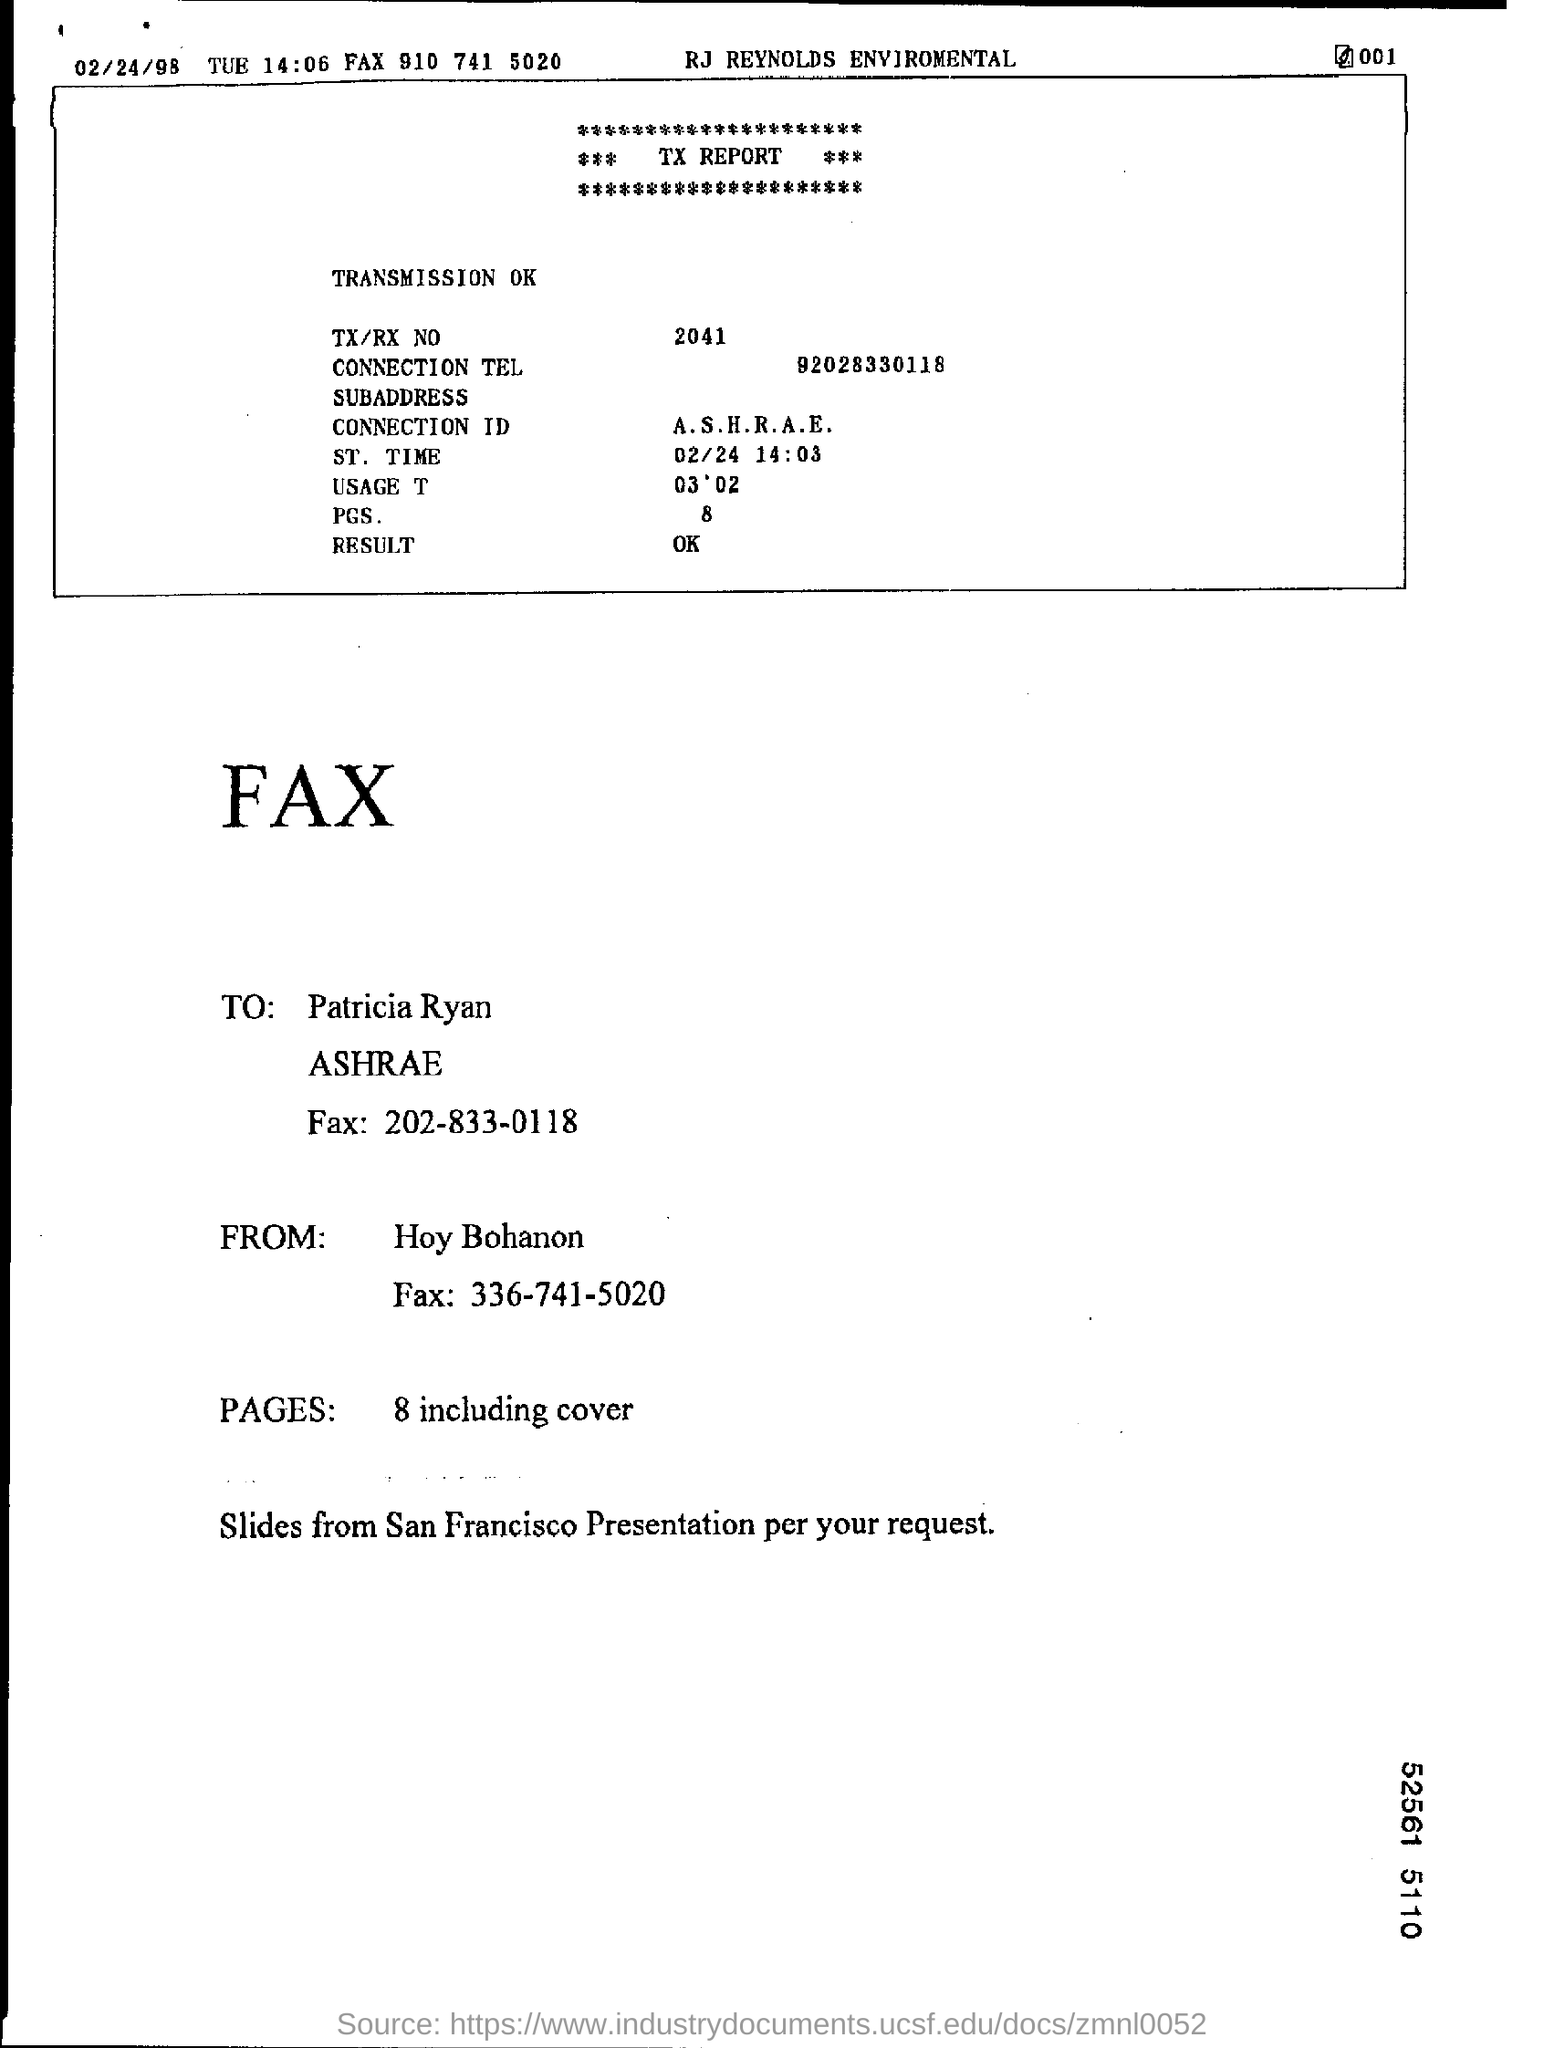What does the abbreviation 'A.S.H.R.A.E.' stand for and what might be their interest in the slides from the San Francisco Presentation? A.S.H.R.A.E. stands for the American Society of Heating, Refrigerating and Air-Conditioning Engineers. Likely, they are interested in the San Francisco Presentation slides for insights or advancements relevant to their industry, potentially to discuss at a conference or in a professional meeting. 